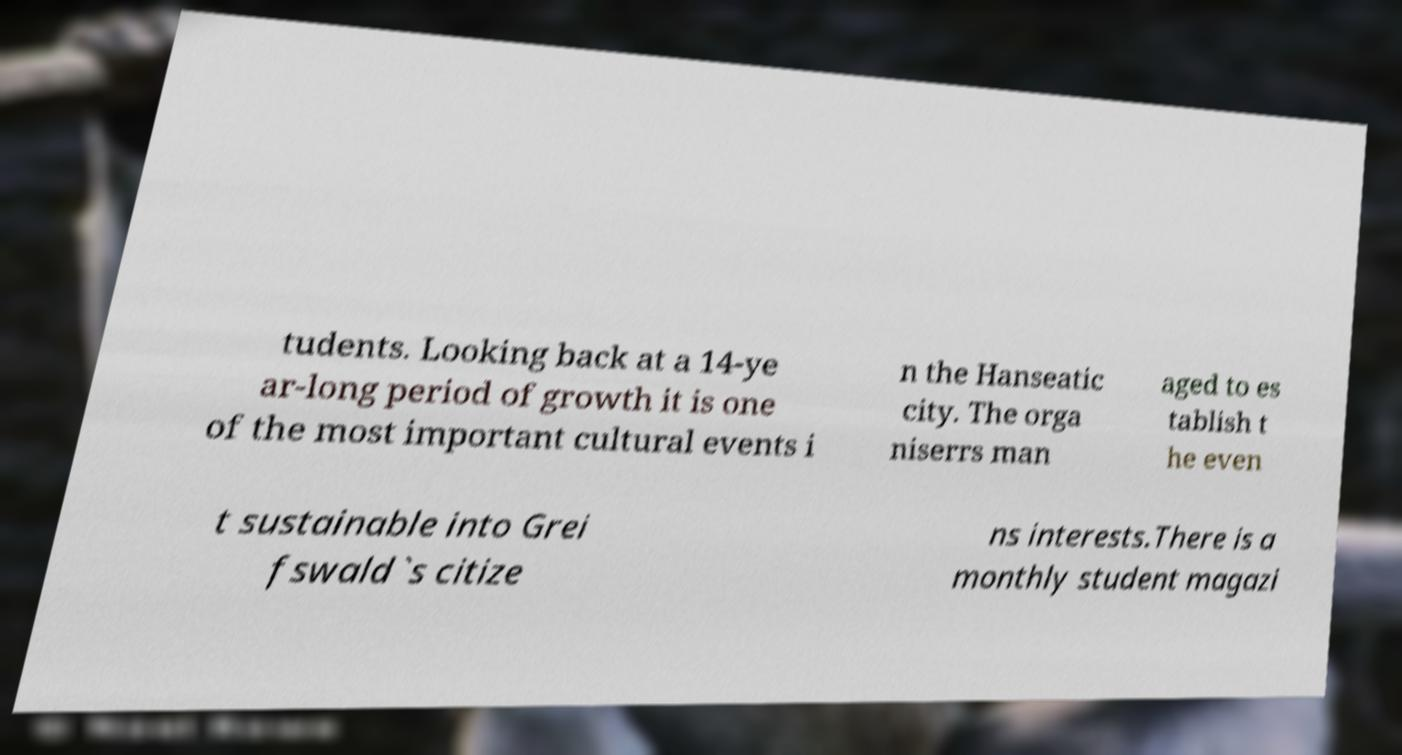Can you read and provide the text displayed in the image?This photo seems to have some interesting text. Can you extract and type it out for me? tudents. Looking back at a 14-ye ar-long period of growth it is one of the most important cultural events i n the Hanseatic city. The orga niserrs man aged to es tablish t he even t sustainable into Grei fswald`s citize ns interests.There is a monthly student magazi 